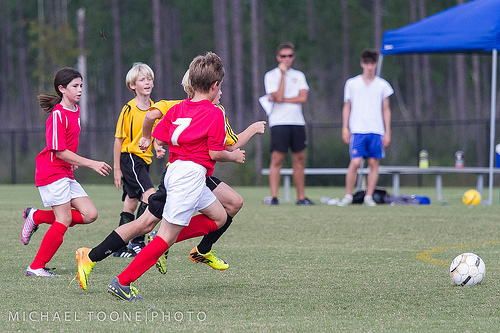<image>
Can you confirm if the boy is to the left of the girl? Yes. From this viewpoint, the boy is positioned to the left side relative to the girl. 